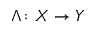Convert formula to latex. <formula><loc_0><loc_0><loc_500><loc_500>\Lambda \colon X \to Y</formula> 